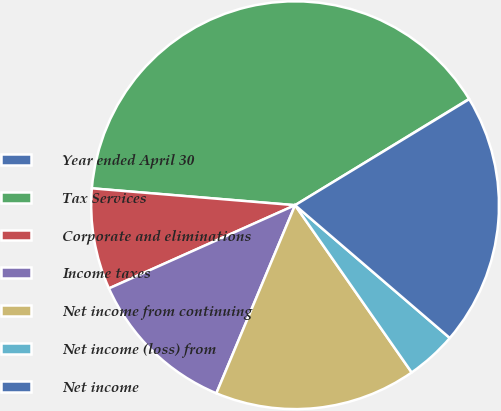<chart> <loc_0><loc_0><loc_500><loc_500><pie_chart><fcel>Year ended April 30<fcel>Tax Services<fcel>Corporate and eliminations<fcel>Income taxes<fcel>Net income from continuing<fcel>Net income (loss) from<fcel>Net income<nl><fcel>0.03%<fcel>39.95%<fcel>8.01%<fcel>12.0%<fcel>16.0%<fcel>4.02%<fcel>19.99%<nl></chart> 